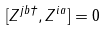<formula> <loc_0><loc_0><loc_500><loc_500>[ Z ^ { j b \dagger } , Z ^ { i a } ] = 0</formula> 